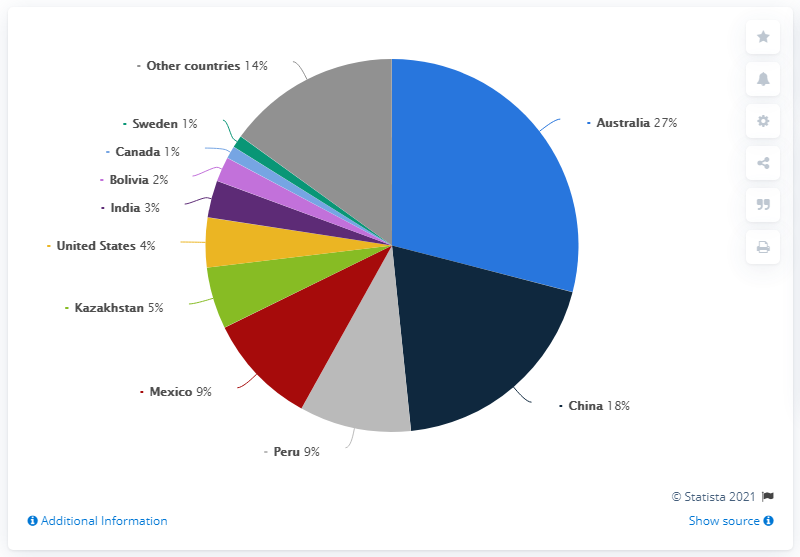Highlight a few significant elements in this photo. Sweden and Canada have the lowest percentage of [whatever the percentage is referring to] among the countries listed. There are 11 categories of countries represented in total. In 2019, Australia had the largest reserves of zinc globally. 